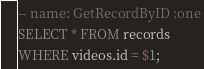<code> <loc_0><loc_0><loc_500><loc_500><_SQL_>-- name: GetRecordByID :one
SELECT * FROM records 
WHERE videos.id = $1;

</code> 